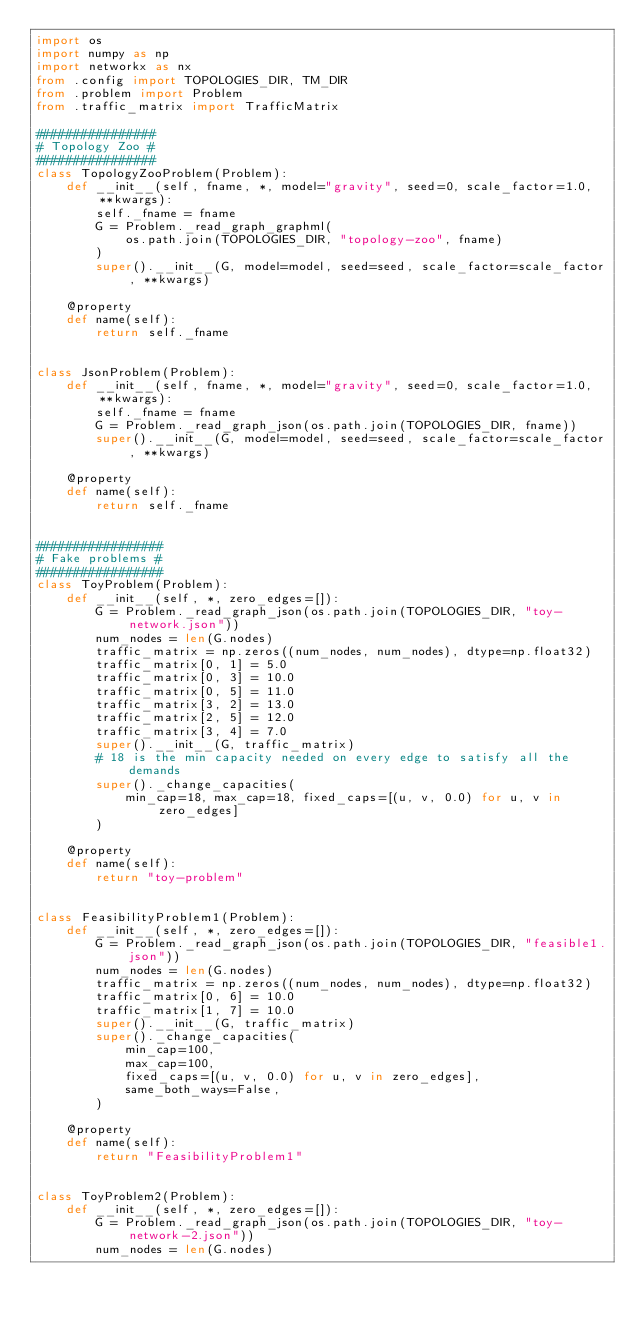<code> <loc_0><loc_0><loc_500><loc_500><_Python_>import os
import numpy as np
import networkx as nx
from .config import TOPOLOGIES_DIR, TM_DIR
from .problem import Problem
from .traffic_matrix import TrafficMatrix

################
# Topology Zoo #
################
class TopologyZooProblem(Problem):
    def __init__(self, fname, *, model="gravity", seed=0, scale_factor=1.0, **kwargs):
        self._fname = fname
        G = Problem._read_graph_graphml(
            os.path.join(TOPOLOGIES_DIR, "topology-zoo", fname)
        )
        super().__init__(G, model=model, seed=seed, scale_factor=scale_factor, **kwargs)

    @property
    def name(self):
        return self._fname


class JsonProblem(Problem):
    def __init__(self, fname, *, model="gravity", seed=0, scale_factor=1.0, **kwargs):
        self._fname = fname
        G = Problem._read_graph_json(os.path.join(TOPOLOGIES_DIR, fname))
        super().__init__(G, model=model, seed=seed, scale_factor=scale_factor, **kwargs)

    @property
    def name(self):
        return self._fname


#################
# Fake problems #
#################
class ToyProblem(Problem):
    def __init__(self, *, zero_edges=[]):
        G = Problem._read_graph_json(os.path.join(TOPOLOGIES_DIR, "toy-network.json"))
        num_nodes = len(G.nodes)
        traffic_matrix = np.zeros((num_nodes, num_nodes), dtype=np.float32)
        traffic_matrix[0, 1] = 5.0
        traffic_matrix[0, 3] = 10.0
        traffic_matrix[0, 5] = 11.0
        traffic_matrix[3, 2] = 13.0
        traffic_matrix[2, 5] = 12.0
        traffic_matrix[3, 4] = 7.0
        super().__init__(G, traffic_matrix)
        # 18 is the min capacity needed on every edge to satisfy all the demands
        super()._change_capacities(
            min_cap=18, max_cap=18, fixed_caps=[(u, v, 0.0) for u, v in zero_edges]
        )

    @property
    def name(self):
        return "toy-problem"


class FeasibilityProblem1(Problem):
    def __init__(self, *, zero_edges=[]):
        G = Problem._read_graph_json(os.path.join(TOPOLOGIES_DIR, "feasible1.json"))
        num_nodes = len(G.nodes)
        traffic_matrix = np.zeros((num_nodes, num_nodes), dtype=np.float32)
        traffic_matrix[0, 6] = 10.0
        traffic_matrix[1, 7] = 10.0
        super().__init__(G, traffic_matrix)
        super()._change_capacities(
            min_cap=100,
            max_cap=100,
            fixed_caps=[(u, v, 0.0) for u, v in zero_edges],
            same_both_ways=False,
        )

    @property
    def name(self):
        return "FeasibilityProblem1"


class ToyProblem2(Problem):
    def __init__(self, *, zero_edges=[]):
        G = Problem._read_graph_json(os.path.join(TOPOLOGIES_DIR, "toy-network-2.json"))
        num_nodes = len(G.nodes)</code> 